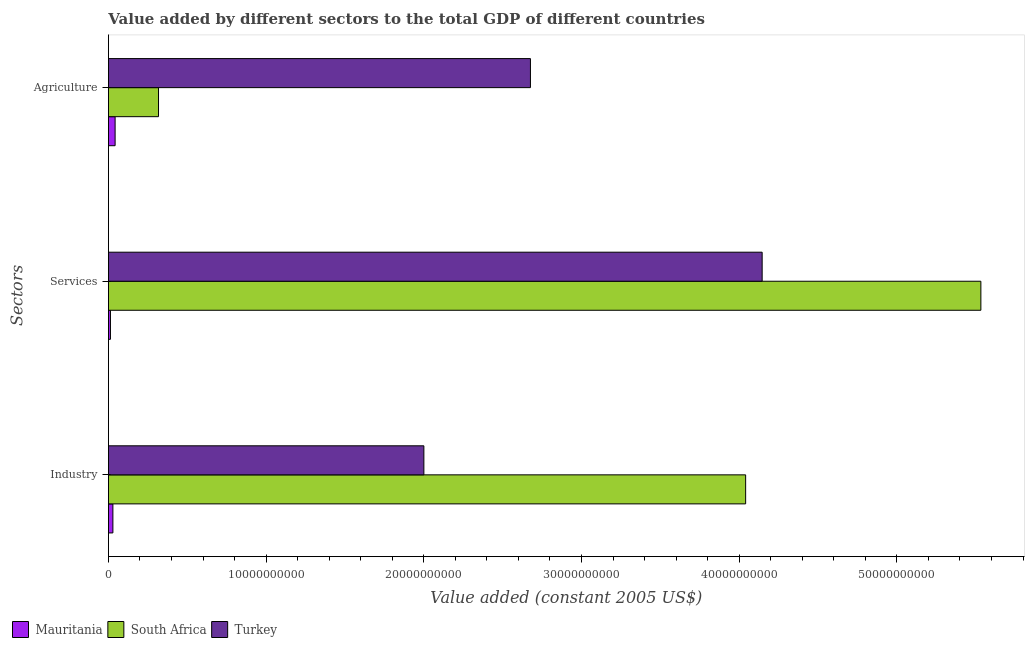How many groups of bars are there?
Offer a very short reply. 3. Are the number of bars per tick equal to the number of legend labels?
Provide a short and direct response. Yes. How many bars are there on the 3rd tick from the top?
Keep it short and to the point. 3. What is the label of the 1st group of bars from the top?
Offer a terse response. Agriculture. What is the value added by agricultural sector in Turkey?
Ensure brevity in your answer.  2.68e+1. Across all countries, what is the maximum value added by agricultural sector?
Your response must be concise. 2.68e+1. Across all countries, what is the minimum value added by industrial sector?
Give a very brief answer. 2.83e+08. In which country was the value added by services maximum?
Offer a terse response. South Africa. In which country was the value added by industrial sector minimum?
Ensure brevity in your answer.  Mauritania. What is the total value added by industrial sector in the graph?
Your response must be concise. 6.07e+1. What is the difference between the value added by services in Turkey and that in Mauritania?
Your response must be concise. 4.13e+1. What is the difference between the value added by industrial sector in Turkey and the value added by services in Mauritania?
Give a very brief answer. 1.99e+1. What is the average value added by agricultural sector per country?
Your answer should be compact. 1.01e+1. What is the difference between the value added by agricultural sector and value added by industrial sector in South Africa?
Keep it short and to the point. -3.72e+1. In how many countries, is the value added by services greater than 8000000000 US$?
Offer a terse response. 2. What is the ratio of the value added by industrial sector in Turkey to that in South Africa?
Your answer should be very brief. 0.5. What is the difference between the highest and the second highest value added by services?
Your response must be concise. 1.39e+1. What is the difference between the highest and the lowest value added by agricultural sector?
Give a very brief answer. 2.63e+1. Is the sum of the value added by agricultural sector in Turkey and Mauritania greater than the maximum value added by services across all countries?
Your response must be concise. No. What does the 3rd bar from the top in Services represents?
Offer a very short reply. Mauritania. What does the 2nd bar from the bottom in Services represents?
Give a very brief answer. South Africa. Is it the case that in every country, the sum of the value added by industrial sector and value added by services is greater than the value added by agricultural sector?
Provide a succinct answer. No. How many bars are there?
Your answer should be very brief. 9. What is the difference between two consecutive major ticks on the X-axis?
Your answer should be very brief. 1.00e+1. Are the values on the major ticks of X-axis written in scientific E-notation?
Your response must be concise. No. Does the graph contain grids?
Your response must be concise. No. How many legend labels are there?
Provide a short and direct response. 3. How are the legend labels stacked?
Offer a terse response. Horizontal. What is the title of the graph?
Offer a very short reply. Value added by different sectors to the total GDP of different countries. What is the label or title of the X-axis?
Keep it short and to the point. Value added (constant 2005 US$). What is the label or title of the Y-axis?
Your response must be concise. Sectors. What is the Value added (constant 2005 US$) of Mauritania in Industry?
Your answer should be very brief. 2.83e+08. What is the Value added (constant 2005 US$) of South Africa in Industry?
Your answer should be compact. 4.04e+1. What is the Value added (constant 2005 US$) of Turkey in Industry?
Your answer should be very brief. 2.00e+1. What is the Value added (constant 2005 US$) of Mauritania in Services?
Offer a terse response. 1.28e+08. What is the Value added (constant 2005 US$) of South Africa in Services?
Offer a very short reply. 5.53e+1. What is the Value added (constant 2005 US$) in Turkey in Services?
Make the answer very short. 4.15e+1. What is the Value added (constant 2005 US$) of Mauritania in Agriculture?
Your answer should be very brief. 4.24e+08. What is the Value added (constant 2005 US$) in South Africa in Agriculture?
Your answer should be very brief. 3.18e+09. What is the Value added (constant 2005 US$) in Turkey in Agriculture?
Your response must be concise. 2.68e+1. Across all Sectors, what is the maximum Value added (constant 2005 US$) in Mauritania?
Offer a very short reply. 4.24e+08. Across all Sectors, what is the maximum Value added (constant 2005 US$) of South Africa?
Make the answer very short. 5.53e+1. Across all Sectors, what is the maximum Value added (constant 2005 US$) in Turkey?
Make the answer very short. 4.15e+1. Across all Sectors, what is the minimum Value added (constant 2005 US$) in Mauritania?
Offer a very short reply. 1.28e+08. Across all Sectors, what is the minimum Value added (constant 2005 US$) of South Africa?
Your answer should be compact. 3.18e+09. Across all Sectors, what is the minimum Value added (constant 2005 US$) in Turkey?
Offer a very short reply. 2.00e+1. What is the total Value added (constant 2005 US$) in Mauritania in the graph?
Provide a succinct answer. 8.35e+08. What is the total Value added (constant 2005 US$) of South Africa in the graph?
Provide a short and direct response. 9.89e+1. What is the total Value added (constant 2005 US$) of Turkey in the graph?
Ensure brevity in your answer.  8.82e+1. What is the difference between the Value added (constant 2005 US$) of Mauritania in Industry and that in Services?
Provide a short and direct response. 1.55e+08. What is the difference between the Value added (constant 2005 US$) of South Africa in Industry and that in Services?
Provide a succinct answer. -1.49e+1. What is the difference between the Value added (constant 2005 US$) of Turkey in Industry and that in Services?
Ensure brevity in your answer.  -2.15e+1. What is the difference between the Value added (constant 2005 US$) of Mauritania in Industry and that in Agriculture?
Provide a succinct answer. -1.40e+08. What is the difference between the Value added (constant 2005 US$) in South Africa in Industry and that in Agriculture?
Give a very brief answer. 3.72e+1. What is the difference between the Value added (constant 2005 US$) of Turkey in Industry and that in Agriculture?
Your response must be concise. -6.76e+09. What is the difference between the Value added (constant 2005 US$) in Mauritania in Services and that in Agriculture?
Make the answer very short. -2.95e+08. What is the difference between the Value added (constant 2005 US$) of South Africa in Services and that in Agriculture?
Offer a very short reply. 5.21e+1. What is the difference between the Value added (constant 2005 US$) in Turkey in Services and that in Agriculture?
Ensure brevity in your answer.  1.47e+1. What is the difference between the Value added (constant 2005 US$) in Mauritania in Industry and the Value added (constant 2005 US$) in South Africa in Services?
Provide a short and direct response. -5.50e+1. What is the difference between the Value added (constant 2005 US$) in Mauritania in Industry and the Value added (constant 2005 US$) in Turkey in Services?
Your response must be concise. -4.12e+1. What is the difference between the Value added (constant 2005 US$) in South Africa in Industry and the Value added (constant 2005 US$) in Turkey in Services?
Your response must be concise. -1.05e+09. What is the difference between the Value added (constant 2005 US$) in Mauritania in Industry and the Value added (constant 2005 US$) in South Africa in Agriculture?
Provide a short and direct response. -2.89e+09. What is the difference between the Value added (constant 2005 US$) of Mauritania in Industry and the Value added (constant 2005 US$) of Turkey in Agriculture?
Make the answer very short. -2.65e+1. What is the difference between the Value added (constant 2005 US$) in South Africa in Industry and the Value added (constant 2005 US$) in Turkey in Agriculture?
Provide a short and direct response. 1.36e+1. What is the difference between the Value added (constant 2005 US$) of Mauritania in Services and the Value added (constant 2005 US$) of South Africa in Agriculture?
Your answer should be very brief. -3.05e+09. What is the difference between the Value added (constant 2005 US$) of Mauritania in Services and the Value added (constant 2005 US$) of Turkey in Agriculture?
Your answer should be very brief. -2.66e+1. What is the difference between the Value added (constant 2005 US$) of South Africa in Services and the Value added (constant 2005 US$) of Turkey in Agriculture?
Your response must be concise. 2.86e+1. What is the average Value added (constant 2005 US$) of Mauritania per Sectors?
Offer a very short reply. 2.78e+08. What is the average Value added (constant 2005 US$) of South Africa per Sectors?
Your response must be concise. 3.30e+1. What is the average Value added (constant 2005 US$) of Turkey per Sectors?
Provide a short and direct response. 2.94e+1. What is the difference between the Value added (constant 2005 US$) of Mauritania and Value added (constant 2005 US$) of South Africa in Industry?
Ensure brevity in your answer.  -4.01e+1. What is the difference between the Value added (constant 2005 US$) in Mauritania and Value added (constant 2005 US$) in Turkey in Industry?
Your response must be concise. -1.97e+1. What is the difference between the Value added (constant 2005 US$) of South Africa and Value added (constant 2005 US$) of Turkey in Industry?
Offer a terse response. 2.04e+1. What is the difference between the Value added (constant 2005 US$) of Mauritania and Value added (constant 2005 US$) of South Africa in Services?
Ensure brevity in your answer.  -5.52e+1. What is the difference between the Value added (constant 2005 US$) in Mauritania and Value added (constant 2005 US$) in Turkey in Services?
Keep it short and to the point. -4.13e+1. What is the difference between the Value added (constant 2005 US$) of South Africa and Value added (constant 2005 US$) of Turkey in Services?
Give a very brief answer. 1.39e+1. What is the difference between the Value added (constant 2005 US$) in Mauritania and Value added (constant 2005 US$) in South Africa in Agriculture?
Ensure brevity in your answer.  -2.75e+09. What is the difference between the Value added (constant 2005 US$) in Mauritania and Value added (constant 2005 US$) in Turkey in Agriculture?
Offer a very short reply. -2.63e+1. What is the difference between the Value added (constant 2005 US$) of South Africa and Value added (constant 2005 US$) of Turkey in Agriculture?
Make the answer very short. -2.36e+1. What is the ratio of the Value added (constant 2005 US$) of Mauritania in Industry to that in Services?
Make the answer very short. 2.21. What is the ratio of the Value added (constant 2005 US$) in South Africa in Industry to that in Services?
Keep it short and to the point. 0.73. What is the ratio of the Value added (constant 2005 US$) of Turkey in Industry to that in Services?
Offer a very short reply. 0.48. What is the ratio of the Value added (constant 2005 US$) of Mauritania in Industry to that in Agriculture?
Provide a succinct answer. 0.67. What is the ratio of the Value added (constant 2005 US$) in South Africa in Industry to that in Agriculture?
Give a very brief answer. 12.72. What is the ratio of the Value added (constant 2005 US$) of Turkey in Industry to that in Agriculture?
Provide a succinct answer. 0.75. What is the ratio of the Value added (constant 2005 US$) in Mauritania in Services to that in Agriculture?
Give a very brief answer. 0.3. What is the ratio of the Value added (constant 2005 US$) in South Africa in Services to that in Agriculture?
Offer a very short reply. 17.42. What is the ratio of the Value added (constant 2005 US$) of Turkey in Services to that in Agriculture?
Keep it short and to the point. 1.55. What is the difference between the highest and the second highest Value added (constant 2005 US$) in Mauritania?
Ensure brevity in your answer.  1.40e+08. What is the difference between the highest and the second highest Value added (constant 2005 US$) in South Africa?
Give a very brief answer. 1.49e+1. What is the difference between the highest and the second highest Value added (constant 2005 US$) in Turkey?
Make the answer very short. 1.47e+1. What is the difference between the highest and the lowest Value added (constant 2005 US$) of Mauritania?
Make the answer very short. 2.95e+08. What is the difference between the highest and the lowest Value added (constant 2005 US$) in South Africa?
Make the answer very short. 5.21e+1. What is the difference between the highest and the lowest Value added (constant 2005 US$) of Turkey?
Ensure brevity in your answer.  2.15e+1. 